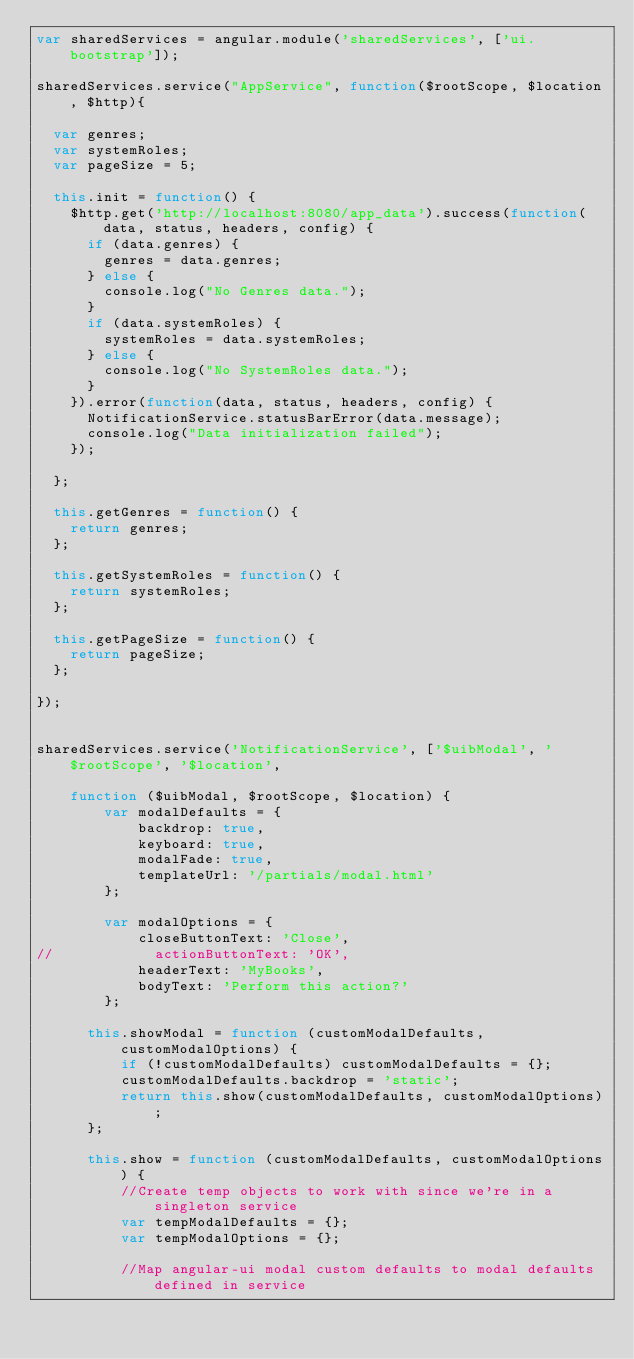Convert code to text. <code><loc_0><loc_0><loc_500><loc_500><_JavaScript_>var sharedServices = angular.module('sharedServices', ['ui.bootstrap']);

sharedServices.service("AppService", function($rootScope, $location, $http){
	
	var genres;
	var systemRoles;
	var pageSize = 5;
	
	this.init = function() {
		$http.get('http://localhost:8080/app_data').success(function(data, status, headers, config) {
			if (data.genres) {
				genres = data.genres;
			} else {
				console.log("No Genres data.");
			}
			if (data.systemRoles) {
				systemRoles = data.systemRoles;
			} else {
				console.log("No SystemRoles data.");
			}
		}).error(function(data, status, headers, config) {
			NotificationService.statusBarError(data.message);
			console.log("Data initialization failed");
		});
		
	};
	
	this.getGenres = function() {
		return genres;
	};
	
	this.getSystemRoles = function() {
		return systemRoles;
	};
	
	this.getPageSize = function() {
		return pageSize;
	};
 
});


sharedServices.service('NotificationService', ['$uibModal', '$rootScope', '$location',

    function ($uibModal, $rootScope, $location) {
        var modalDefaults = {
        		backdrop: true,
        		keyboard: true,
        		modalFade: true,
        		templateUrl: '/partials/modal.html'
        };

        var modalOptions = {
        		closeButtonText: 'Close',
//        		actionButtonText: 'OK',
        		headerText: 'MyBooks',
        		bodyText: 'Perform this action?'
        };

      this.showModal = function (customModalDefaults, customModalOptions) {
          if (!customModalDefaults) customModalDefaults = {};
          customModalDefaults.backdrop = 'static';
          return this.show(customModalDefaults, customModalOptions);
      };

      this.show = function (customModalDefaults, customModalOptions) {
          //Create temp objects to work with since we're in a singleton service
          var tempModalDefaults = {};
          var tempModalOptions = {};

          //Map angular-ui modal custom defaults to modal defaults defined in service</code> 